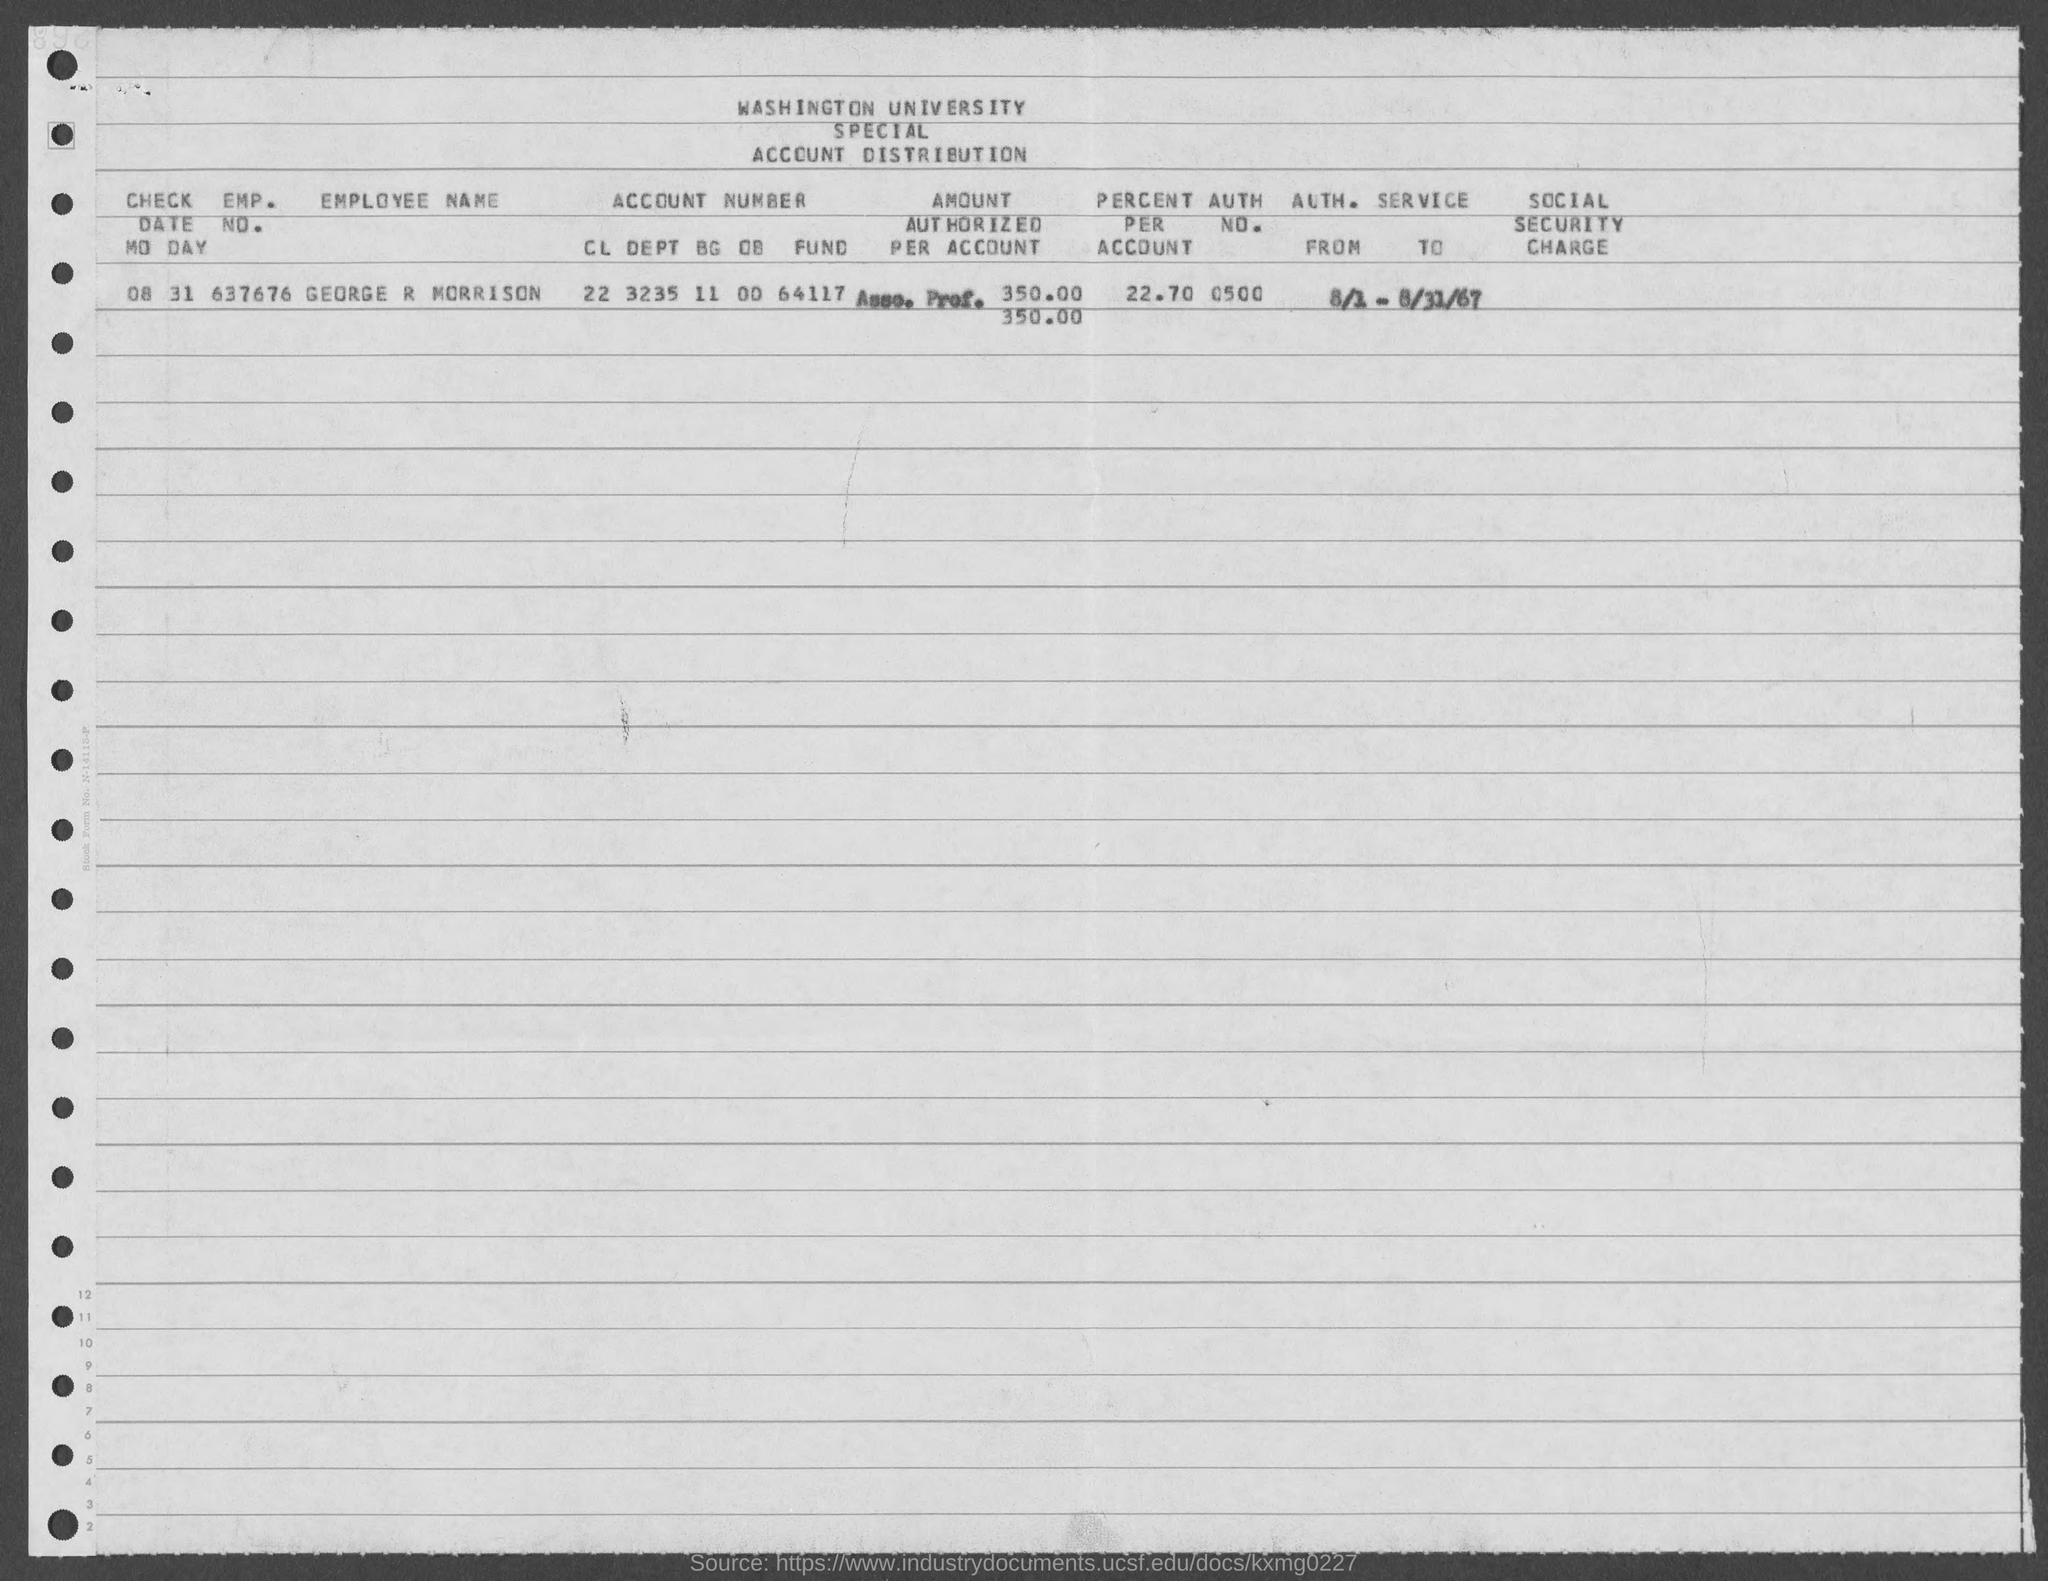List a handful of essential elements in this visual. The value of "percent per account" is 22.70, as stated in the given form. The check date mentioned in the given form is August 31. The emp. no. mentioned in the given form is 637676... The given form mentions the name "George R Morrison. The authorization number mentioned in the provided form is 0500... 